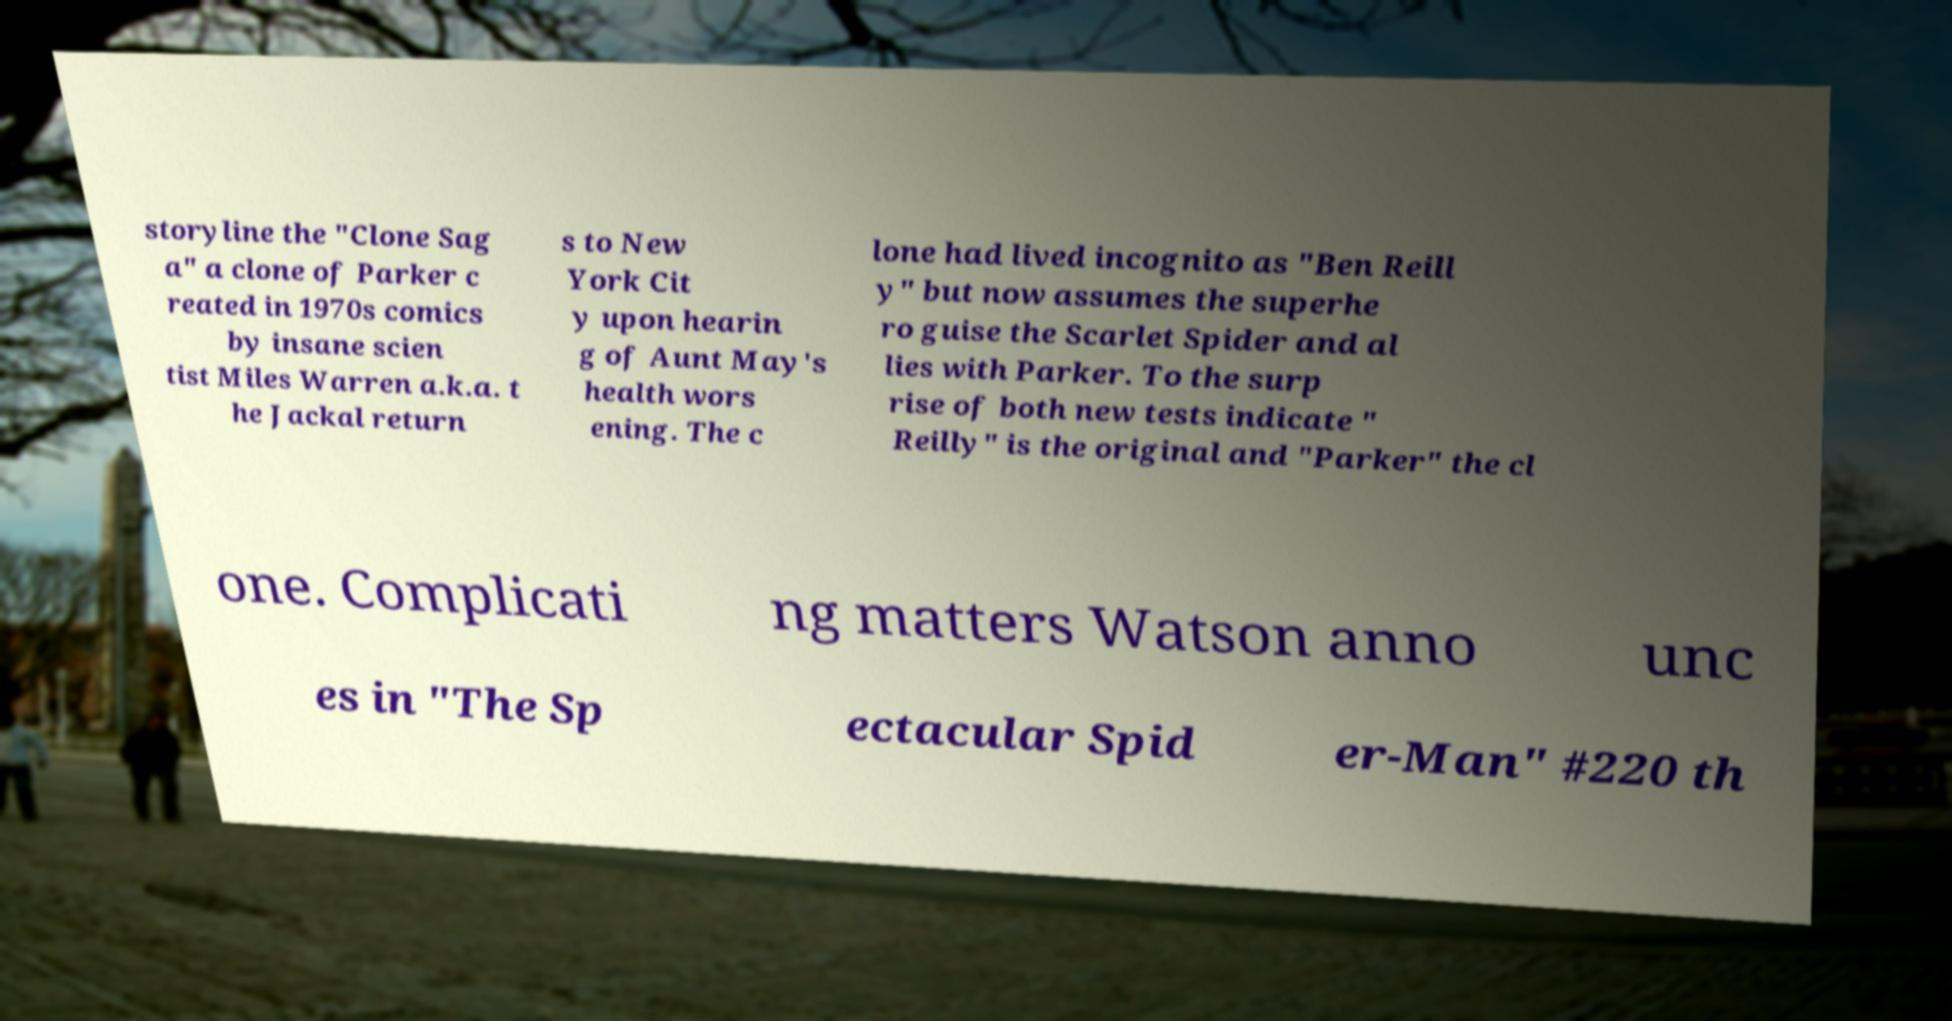Can you read and provide the text displayed in the image?This photo seems to have some interesting text. Can you extract and type it out for me? storyline the "Clone Sag a" a clone of Parker c reated in 1970s comics by insane scien tist Miles Warren a.k.a. t he Jackal return s to New York Cit y upon hearin g of Aunt May's health wors ening. The c lone had lived incognito as "Ben Reill y" but now assumes the superhe ro guise the Scarlet Spider and al lies with Parker. To the surp rise of both new tests indicate " Reilly" is the original and "Parker" the cl one. Complicati ng matters Watson anno unc es in "The Sp ectacular Spid er-Man" #220 th 